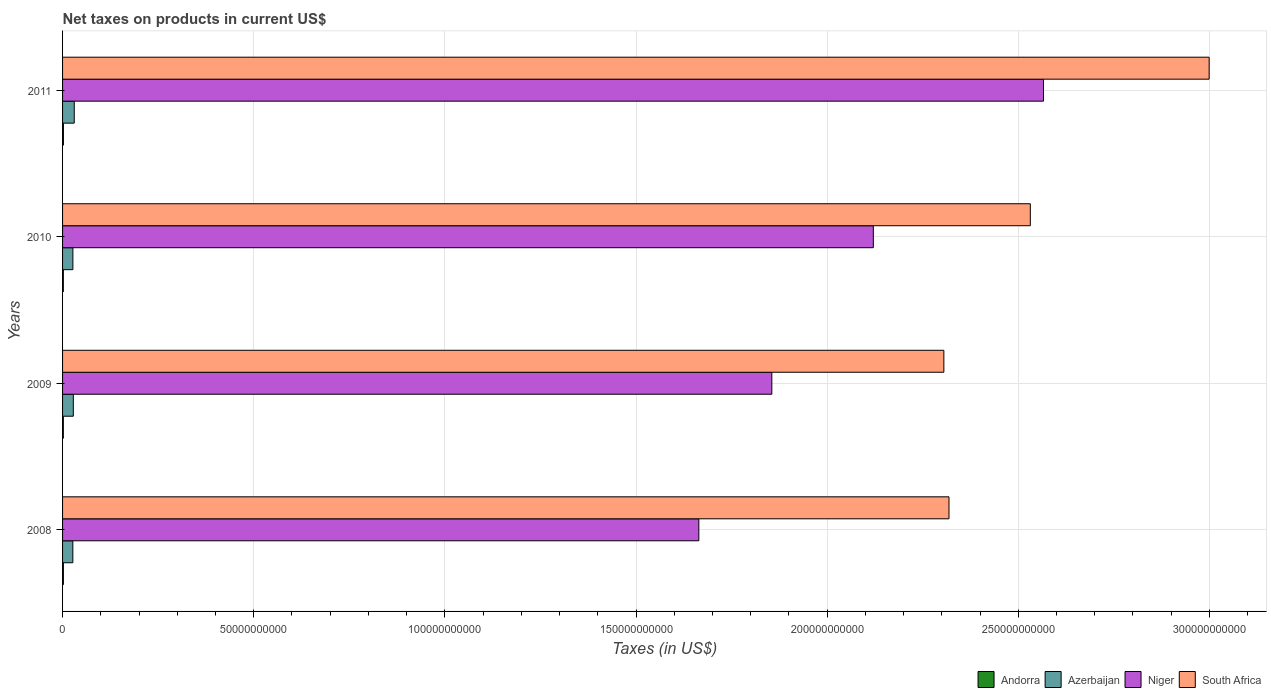What is the net taxes on products in South Africa in 2009?
Provide a succinct answer. 2.31e+11. Across all years, what is the maximum net taxes on products in Andorra?
Make the answer very short. 2.25e+08. Across all years, what is the minimum net taxes on products in Andorra?
Give a very brief answer. 2.02e+08. In which year was the net taxes on products in South Africa minimum?
Provide a short and direct response. 2009. What is the total net taxes on products in South Africa in the graph?
Offer a terse response. 1.02e+12. What is the difference between the net taxes on products in Andorra in 2009 and that in 2011?
Provide a succinct answer. -2.26e+07. What is the difference between the net taxes on products in Azerbaijan in 2009 and the net taxes on products in Andorra in 2008?
Your response must be concise. 2.60e+09. What is the average net taxes on products in Andorra per year?
Your answer should be compact. 2.11e+08. In the year 2011, what is the difference between the net taxes on products in South Africa and net taxes on products in Niger?
Provide a succinct answer. 4.33e+1. What is the ratio of the net taxes on products in Niger in 2010 to that in 2011?
Offer a very short reply. 0.83. Is the net taxes on products in South Africa in 2009 less than that in 2011?
Offer a terse response. Yes. What is the difference between the highest and the second highest net taxes on products in South Africa?
Your response must be concise. 4.68e+1. What is the difference between the highest and the lowest net taxes on products in Andorra?
Make the answer very short. 2.26e+07. In how many years, is the net taxes on products in Andorra greater than the average net taxes on products in Andorra taken over all years?
Offer a very short reply. 2. What does the 2nd bar from the top in 2011 represents?
Your answer should be very brief. Niger. What does the 1st bar from the bottom in 2011 represents?
Your response must be concise. Andorra. Is it the case that in every year, the sum of the net taxes on products in South Africa and net taxes on products in Niger is greater than the net taxes on products in Andorra?
Provide a succinct answer. Yes. How many bars are there?
Your response must be concise. 16. Are all the bars in the graph horizontal?
Your answer should be compact. Yes. What is the difference between two consecutive major ticks on the X-axis?
Provide a short and direct response. 5.00e+1. Are the values on the major ticks of X-axis written in scientific E-notation?
Provide a succinct answer. No. Does the graph contain any zero values?
Provide a short and direct response. No. How many legend labels are there?
Ensure brevity in your answer.  4. How are the legend labels stacked?
Your answer should be compact. Horizontal. What is the title of the graph?
Give a very brief answer. Net taxes on products in current US$. What is the label or title of the X-axis?
Provide a short and direct response. Taxes (in US$). What is the label or title of the Y-axis?
Give a very brief answer. Years. What is the Taxes (in US$) in Andorra in 2008?
Offer a very short reply. 2.14e+08. What is the Taxes (in US$) in Azerbaijan in 2008?
Ensure brevity in your answer.  2.69e+09. What is the Taxes (in US$) in Niger in 2008?
Provide a succinct answer. 1.66e+11. What is the Taxes (in US$) of South Africa in 2008?
Provide a succinct answer. 2.32e+11. What is the Taxes (in US$) in Andorra in 2009?
Give a very brief answer. 2.02e+08. What is the Taxes (in US$) of Azerbaijan in 2009?
Your answer should be very brief. 2.81e+09. What is the Taxes (in US$) of Niger in 2009?
Provide a succinct answer. 1.86e+11. What is the Taxes (in US$) of South Africa in 2009?
Your response must be concise. 2.31e+11. What is the Taxes (in US$) of Andorra in 2010?
Ensure brevity in your answer.  2.02e+08. What is the Taxes (in US$) in Azerbaijan in 2010?
Give a very brief answer. 2.70e+09. What is the Taxes (in US$) of Niger in 2010?
Provide a short and direct response. 2.12e+11. What is the Taxes (in US$) of South Africa in 2010?
Offer a terse response. 2.53e+11. What is the Taxes (in US$) of Andorra in 2011?
Provide a succinct answer. 2.25e+08. What is the Taxes (in US$) in Azerbaijan in 2011?
Your response must be concise. 3.06e+09. What is the Taxes (in US$) in Niger in 2011?
Keep it short and to the point. 2.57e+11. What is the Taxes (in US$) of South Africa in 2011?
Provide a succinct answer. 3.00e+11. Across all years, what is the maximum Taxes (in US$) of Andorra?
Keep it short and to the point. 2.25e+08. Across all years, what is the maximum Taxes (in US$) of Azerbaijan?
Give a very brief answer. 3.06e+09. Across all years, what is the maximum Taxes (in US$) in Niger?
Offer a very short reply. 2.57e+11. Across all years, what is the maximum Taxes (in US$) in South Africa?
Keep it short and to the point. 3.00e+11. Across all years, what is the minimum Taxes (in US$) of Andorra?
Offer a very short reply. 2.02e+08. Across all years, what is the minimum Taxes (in US$) of Azerbaijan?
Make the answer very short. 2.69e+09. Across all years, what is the minimum Taxes (in US$) in Niger?
Ensure brevity in your answer.  1.66e+11. Across all years, what is the minimum Taxes (in US$) in South Africa?
Make the answer very short. 2.31e+11. What is the total Taxes (in US$) in Andorra in the graph?
Offer a terse response. 8.43e+08. What is the total Taxes (in US$) of Azerbaijan in the graph?
Offer a terse response. 1.13e+1. What is the total Taxes (in US$) of Niger in the graph?
Ensure brevity in your answer.  8.21e+11. What is the total Taxes (in US$) of South Africa in the graph?
Make the answer very short. 1.02e+12. What is the difference between the Taxes (in US$) of Andorra in 2008 and that in 2009?
Give a very brief answer. 1.18e+07. What is the difference between the Taxes (in US$) in Azerbaijan in 2008 and that in 2009?
Keep it short and to the point. -1.21e+08. What is the difference between the Taxes (in US$) of Niger in 2008 and that in 2009?
Ensure brevity in your answer.  -1.91e+1. What is the difference between the Taxes (in US$) of South Africa in 2008 and that in 2009?
Offer a very short reply. 1.34e+09. What is the difference between the Taxes (in US$) in Andorra in 2008 and that in 2010?
Ensure brevity in your answer.  1.16e+07. What is the difference between the Taxes (in US$) in Azerbaijan in 2008 and that in 2010?
Your response must be concise. -1.10e+07. What is the difference between the Taxes (in US$) in Niger in 2008 and that in 2010?
Provide a succinct answer. -4.56e+1. What is the difference between the Taxes (in US$) of South Africa in 2008 and that in 2010?
Give a very brief answer. -2.13e+1. What is the difference between the Taxes (in US$) in Andorra in 2008 and that in 2011?
Your answer should be compact. -1.08e+07. What is the difference between the Taxes (in US$) in Azerbaijan in 2008 and that in 2011?
Provide a succinct answer. -3.67e+08. What is the difference between the Taxes (in US$) of Niger in 2008 and that in 2011?
Your answer should be very brief. -9.02e+1. What is the difference between the Taxes (in US$) of South Africa in 2008 and that in 2011?
Keep it short and to the point. -6.81e+1. What is the difference between the Taxes (in US$) of Azerbaijan in 2009 and that in 2010?
Provide a short and direct response. 1.10e+08. What is the difference between the Taxes (in US$) in Niger in 2009 and that in 2010?
Give a very brief answer. -2.66e+1. What is the difference between the Taxes (in US$) of South Africa in 2009 and that in 2010?
Ensure brevity in your answer.  -2.26e+1. What is the difference between the Taxes (in US$) of Andorra in 2009 and that in 2011?
Make the answer very short. -2.26e+07. What is the difference between the Taxes (in US$) of Azerbaijan in 2009 and that in 2011?
Keep it short and to the point. -2.46e+08. What is the difference between the Taxes (in US$) of Niger in 2009 and that in 2011?
Provide a short and direct response. -7.11e+1. What is the difference between the Taxes (in US$) in South Africa in 2009 and that in 2011?
Your answer should be compact. -6.94e+1. What is the difference between the Taxes (in US$) of Andorra in 2010 and that in 2011?
Provide a succinct answer. -2.25e+07. What is the difference between the Taxes (in US$) in Azerbaijan in 2010 and that in 2011?
Ensure brevity in your answer.  -3.56e+08. What is the difference between the Taxes (in US$) in Niger in 2010 and that in 2011?
Provide a succinct answer. -4.45e+1. What is the difference between the Taxes (in US$) of South Africa in 2010 and that in 2011?
Give a very brief answer. -4.68e+1. What is the difference between the Taxes (in US$) in Andorra in 2008 and the Taxes (in US$) in Azerbaijan in 2009?
Ensure brevity in your answer.  -2.60e+09. What is the difference between the Taxes (in US$) in Andorra in 2008 and the Taxes (in US$) in Niger in 2009?
Your answer should be compact. -1.85e+11. What is the difference between the Taxes (in US$) in Andorra in 2008 and the Taxes (in US$) in South Africa in 2009?
Ensure brevity in your answer.  -2.30e+11. What is the difference between the Taxes (in US$) of Azerbaijan in 2008 and the Taxes (in US$) of Niger in 2009?
Your answer should be compact. -1.83e+11. What is the difference between the Taxes (in US$) of Azerbaijan in 2008 and the Taxes (in US$) of South Africa in 2009?
Provide a short and direct response. -2.28e+11. What is the difference between the Taxes (in US$) in Niger in 2008 and the Taxes (in US$) in South Africa in 2009?
Your answer should be very brief. -6.41e+1. What is the difference between the Taxes (in US$) of Andorra in 2008 and the Taxes (in US$) of Azerbaijan in 2010?
Ensure brevity in your answer.  -2.49e+09. What is the difference between the Taxes (in US$) of Andorra in 2008 and the Taxes (in US$) of Niger in 2010?
Give a very brief answer. -2.12e+11. What is the difference between the Taxes (in US$) of Andorra in 2008 and the Taxes (in US$) of South Africa in 2010?
Offer a very short reply. -2.53e+11. What is the difference between the Taxes (in US$) in Azerbaijan in 2008 and the Taxes (in US$) in Niger in 2010?
Offer a terse response. -2.09e+11. What is the difference between the Taxes (in US$) of Azerbaijan in 2008 and the Taxes (in US$) of South Africa in 2010?
Ensure brevity in your answer.  -2.50e+11. What is the difference between the Taxes (in US$) of Niger in 2008 and the Taxes (in US$) of South Africa in 2010?
Offer a terse response. -8.67e+1. What is the difference between the Taxes (in US$) of Andorra in 2008 and the Taxes (in US$) of Azerbaijan in 2011?
Keep it short and to the point. -2.84e+09. What is the difference between the Taxes (in US$) in Andorra in 2008 and the Taxes (in US$) in Niger in 2011?
Your response must be concise. -2.56e+11. What is the difference between the Taxes (in US$) in Andorra in 2008 and the Taxes (in US$) in South Africa in 2011?
Your answer should be compact. -3.00e+11. What is the difference between the Taxes (in US$) of Azerbaijan in 2008 and the Taxes (in US$) of Niger in 2011?
Your answer should be compact. -2.54e+11. What is the difference between the Taxes (in US$) of Azerbaijan in 2008 and the Taxes (in US$) of South Africa in 2011?
Provide a succinct answer. -2.97e+11. What is the difference between the Taxes (in US$) in Niger in 2008 and the Taxes (in US$) in South Africa in 2011?
Make the answer very short. -1.33e+11. What is the difference between the Taxes (in US$) of Andorra in 2009 and the Taxes (in US$) of Azerbaijan in 2010?
Give a very brief answer. -2.50e+09. What is the difference between the Taxes (in US$) in Andorra in 2009 and the Taxes (in US$) in Niger in 2010?
Make the answer very short. -2.12e+11. What is the difference between the Taxes (in US$) of Andorra in 2009 and the Taxes (in US$) of South Africa in 2010?
Give a very brief answer. -2.53e+11. What is the difference between the Taxes (in US$) of Azerbaijan in 2009 and the Taxes (in US$) of Niger in 2010?
Provide a succinct answer. -2.09e+11. What is the difference between the Taxes (in US$) of Azerbaijan in 2009 and the Taxes (in US$) of South Africa in 2010?
Your answer should be very brief. -2.50e+11. What is the difference between the Taxes (in US$) of Niger in 2009 and the Taxes (in US$) of South Africa in 2010?
Your answer should be very brief. -6.76e+1. What is the difference between the Taxes (in US$) in Andorra in 2009 and the Taxes (in US$) in Azerbaijan in 2011?
Offer a very short reply. -2.85e+09. What is the difference between the Taxes (in US$) in Andorra in 2009 and the Taxes (in US$) in Niger in 2011?
Give a very brief answer. -2.56e+11. What is the difference between the Taxes (in US$) in Andorra in 2009 and the Taxes (in US$) in South Africa in 2011?
Your answer should be very brief. -3.00e+11. What is the difference between the Taxes (in US$) in Azerbaijan in 2009 and the Taxes (in US$) in Niger in 2011?
Ensure brevity in your answer.  -2.54e+11. What is the difference between the Taxes (in US$) in Azerbaijan in 2009 and the Taxes (in US$) in South Africa in 2011?
Provide a short and direct response. -2.97e+11. What is the difference between the Taxes (in US$) in Niger in 2009 and the Taxes (in US$) in South Africa in 2011?
Provide a short and direct response. -1.14e+11. What is the difference between the Taxes (in US$) of Andorra in 2010 and the Taxes (in US$) of Azerbaijan in 2011?
Provide a succinct answer. -2.85e+09. What is the difference between the Taxes (in US$) in Andorra in 2010 and the Taxes (in US$) in Niger in 2011?
Make the answer very short. -2.56e+11. What is the difference between the Taxes (in US$) in Andorra in 2010 and the Taxes (in US$) in South Africa in 2011?
Offer a very short reply. -3.00e+11. What is the difference between the Taxes (in US$) in Azerbaijan in 2010 and the Taxes (in US$) in Niger in 2011?
Keep it short and to the point. -2.54e+11. What is the difference between the Taxes (in US$) of Azerbaijan in 2010 and the Taxes (in US$) of South Africa in 2011?
Provide a succinct answer. -2.97e+11. What is the difference between the Taxes (in US$) of Niger in 2010 and the Taxes (in US$) of South Africa in 2011?
Your answer should be very brief. -8.78e+1. What is the average Taxes (in US$) of Andorra per year?
Make the answer very short. 2.11e+08. What is the average Taxes (in US$) of Azerbaijan per year?
Your answer should be compact. 2.81e+09. What is the average Taxes (in US$) of Niger per year?
Provide a succinct answer. 2.05e+11. What is the average Taxes (in US$) of South Africa per year?
Keep it short and to the point. 2.54e+11. In the year 2008, what is the difference between the Taxes (in US$) of Andorra and Taxes (in US$) of Azerbaijan?
Provide a succinct answer. -2.47e+09. In the year 2008, what is the difference between the Taxes (in US$) in Andorra and Taxes (in US$) in Niger?
Offer a very short reply. -1.66e+11. In the year 2008, what is the difference between the Taxes (in US$) of Andorra and Taxes (in US$) of South Africa?
Provide a succinct answer. -2.32e+11. In the year 2008, what is the difference between the Taxes (in US$) in Azerbaijan and Taxes (in US$) in Niger?
Offer a terse response. -1.64e+11. In the year 2008, what is the difference between the Taxes (in US$) in Azerbaijan and Taxes (in US$) in South Africa?
Give a very brief answer. -2.29e+11. In the year 2008, what is the difference between the Taxes (in US$) of Niger and Taxes (in US$) of South Africa?
Provide a short and direct response. -6.54e+1. In the year 2009, what is the difference between the Taxes (in US$) in Andorra and Taxes (in US$) in Azerbaijan?
Your response must be concise. -2.61e+09. In the year 2009, what is the difference between the Taxes (in US$) of Andorra and Taxes (in US$) of Niger?
Keep it short and to the point. -1.85e+11. In the year 2009, what is the difference between the Taxes (in US$) in Andorra and Taxes (in US$) in South Africa?
Offer a very short reply. -2.30e+11. In the year 2009, what is the difference between the Taxes (in US$) of Azerbaijan and Taxes (in US$) of Niger?
Provide a succinct answer. -1.83e+11. In the year 2009, what is the difference between the Taxes (in US$) of Azerbaijan and Taxes (in US$) of South Africa?
Offer a very short reply. -2.28e+11. In the year 2009, what is the difference between the Taxes (in US$) of Niger and Taxes (in US$) of South Africa?
Keep it short and to the point. -4.50e+1. In the year 2010, what is the difference between the Taxes (in US$) of Andorra and Taxes (in US$) of Azerbaijan?
Your response must be concise. -2.50e+09. In the year 2010, what is the difference between the Taxes (in US$) of Andorra and Taxes (in US$) of Niger?
Provide a short and direct response. -2.12e+11. In the year 2010, what is the difference between the Taxes (in US$) of Andorra and Taxes (in US$) of South Africa?
Ensure brevity in your answer.  -2.53e+11. In the year 2010, what is the difference between the Taxes (in US$) in Azerbaijan and Taxes (in US$) in Niger?
Keep it short and to the point. -2.09e+11. In the year 2010, what is the difference between the Taxes (in US$) in Azerbaijan and Taxes (in US$) in South Africa?
Make the answer very short. -2.50e+11. In the year 2010, what is the difference between the Taxes (in US$) in Niger and Taxes (in US$) in South Africa?
Provide a succinct answer. -4.11e+1. In the year 2011, what is the difference between the Taxes (in US$) in Andorra and Taxes (in US$) in Azerbaijan?
Your answer should be very brief. -2.83e+09. In the year 2011, what is the difference between the Taxes (in US$) in Andorra and Taxes (in US$) in Niger?
Your answer should be very brief. -2.56e+11. In the year 2011, what is the difference between the Taxes (in US$) in Andorra and Taxes (in US$) in South Africa?
Your answer should be compact. -3.00e+11. In the year 2011, what is the difference between the Taxes (in US$) in Azerbaijan and Taxes (in US$) in Niger?
Offer a terse response. -2.54e+11. In the year 2011, what is the difference between the Taxes (in US$) of Azerbaijan and Taxes (in US$) of South Africa?
Your answer should be compact. -2.97e+11. In the year 2011, what is the difference between the Taxes (in US$) in Niger and Taxes (in US$) in South Africa?
Offer a terse response. -4.33e+1. What is the ratio of the Taxes (in US$) in Andorra in 2008 to that in 2009?
Ensure brevity in your answer.  1.06. What is the ratio of the Taxes (in US$) of Azerbaijan in 2008 to that in 2009?
Offer a terse response. 0.96. What is the ratio of the Taxes (in US$) of Niger in 2008 to that in 2009?
Ensure brevity in your answer.  0.9. What is the ratio of the Taxes (in US$) in Andorra in 2008 to that in 2010?
Offer a terse response. 1.06. What is the ratio of the Taxes (in US$) of Azerbaijan in 2008 to that in 2010?
Offer a very short reply. 1. What is the ratio of the Taxes (in US$) of Niger in 2008 to that in 2010?
Your answer should be very brief. 0.78. What is the ratio of the Taxes (in US$) of South Africa in 2008 to that in 2010?
Your answer should be compact. 0.92. What is the ratio of the Taxes (in US$) in Andorra in 2008 to that in 2011?
Make the answer very short. 0.95. What is the ratio of the Taxes (in US$) in Azerbaijan in 2008 to that in 2011?
Give a very brief answer. 0.88. What is the ratio of the Taxes (in US$) of Niger in 2008 to that in 2011?
Your answer should be compact. 0.65. What is the ratio of the Taxes (in US$) of South Africa in 2008 to that in 2011?
Your answer should be compact. 0.77. What is the ratio of the Taxes (in US$) in Azerbaijan in 2009 to that in 2010?
Make the answer very short. 1.04. What is the ratio of the Taxes (in US$) of Niger in 2009 to that in 2010?
Give a very brief answer. 0.87. What is the ratio of the Taxes (in US$) of South Africa in 2009 to that in 2010?
Offer a terse response. 0.91. What is the ratio of the Taxes (in US$) of Andorra in 2009 to that in 2011?
Keep it short and to the point. 0.9. What is the ratio of the Taxes (in US$) of Azerbaijan in 2009 to that in 2011?
Provide a succinct answer. 0.92. What is the ratio of the Taxes (in US$) of Niger in 2009 to that in 2011?
Offer a very short reply. 0.72. What is the ratio of the Taxes (in US$) of South Africa in 2009 to that in 2011?
Make the answer very short. 0.77. What is the ratio of the Taxes (in US$) of Azerbaijan in 2010 to that in 2011?
Your response must be concise. 0.88. What is the ratio of the Taxes (in US$) in Niger in 2010 to that in 2011?
Make the answer very short. 0.83. What is the ratio of the Taxes (in US$) of South Africa in 2010 to that in 2011?
Your answer should be very brief. 0.84. What is the difference between the highest and the second highest Taxes (in US$) of Andorra?
Your answer should be very brief. 1.08e+07. What is the difference between the highest and the second highest Taxes (in US$) in Azerbaijan?
Provide a short and direct response. 2.46e+08. What is the difference between the highest and the second highest Taxes (in US$) of Niger?
Give a very brief answer. 4.45e+1. What is the difference between the highest and the second highest Taxes (in US$) in South Africa?
Give a very brief answer. 4.68e+1. What is the difference between the highest and the lowest Taxes (in US$) of Andorra?
Provide a succinct answer. 2.26e+07. What is the difference between the highest and the lowest Taxes (in US$) of Azerbaijan?
Your answer should be compact. 3.67e+08. What is the difference between the highest and the lowest Taxes (in US$) in Niger?
Your answer should be very brief. 9.02e+1. What is the difference between the highest and the lowest Taxes (in US$) in South Africa?
Provide a short and direct response. 6.94e+1. 